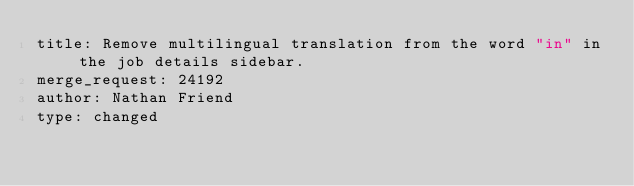<code> <loc_0><loc_0><loc_500><loc_500><_YAML_>title: Remove multilingual translation from the word "in" in the job details sidebar.
merge_request: 24192
author: Nathan Friend
type: changed
</code> 